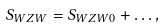<formula> <loc_0><loc_0><loc_500><loc_500>S _ { W Z W } = S _ { W Z W 0 } + \dots ,</formula> 